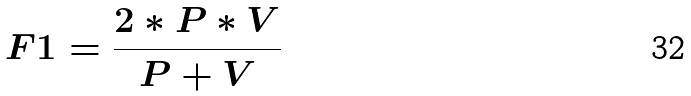<formula> <loc_0><loc_0><loc_500><loc_500>F 1 = \frac { 2 * P * V } { P + V }</formula> 